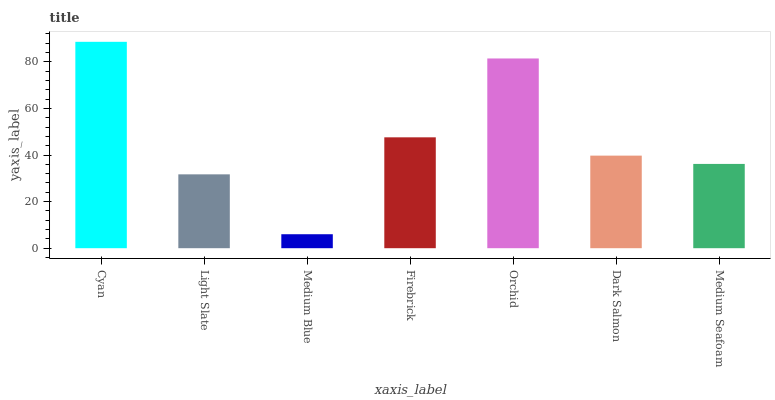Is Light Slate the minimum?
Answer yes or no. No. Is Light Slate the maximum?
Answer yes or no. No. Is Cyan greater than Light Slate?
Answer yes or no. Yes. Is Light Slate less than Cyan?
Answer yes or no. Yes. Is Light Slate greater than Cyan?
Answer yes or no. No. Is Cyan less than Light Slate?
Answer yes or no. No. Is Dark Salmon the high median?
Answer yes or no. Yes. Is Dark Salmon the low median?
Answer yes or no. Yes. Is Light Slate the high median?
Answer yes or no. No. Is Firebrick the low median?
Answer yes or no. No. 